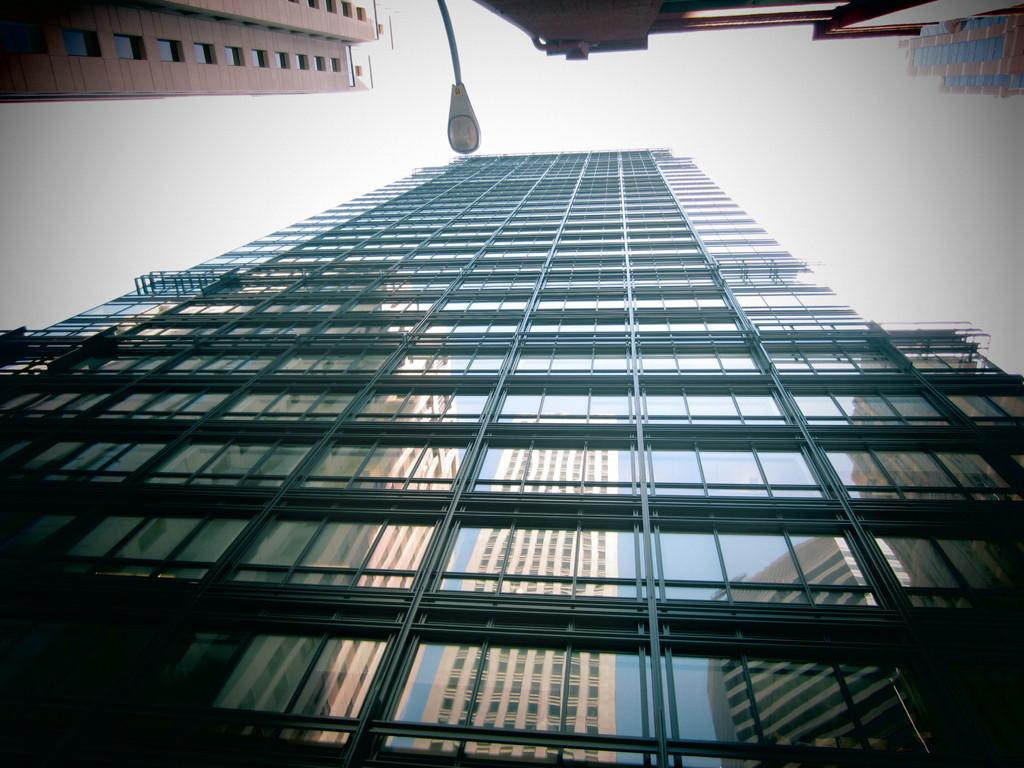What is the main subject of the image? The main subject of the image is a very big building. Can you describe any other objects or features in the image? Yes, there is a street light in the middle of the image. How would you describe the sky in the image? The sky appears to be cloudy in the image. What type of haircut is the building getting in the image? There is no haircut being performed on the building in the image, as buildings do not have hair. 